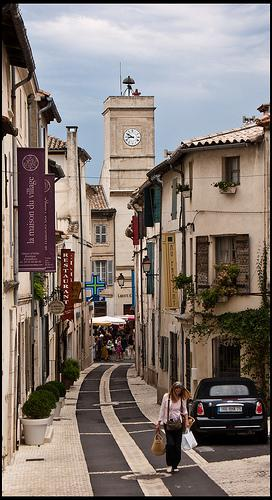State the key elements visible in the picture along with their colors. There is a woman in black pants, a black car, two shopping bags (white and brown), a clock tower, green plants in pots, and hanging banners. Mention the main object of focus in the image and its prominent feature. A woman wearing black pants and carrying white and brown shopping bags is walking on the street. List the items that are being carried or held by someone in the image. tan bag, big white bag, brown shopping bag, white shopping bag Write a sentence describing the most notable action taking place in the image. The woman with long hair, wearing black pants, is walking alone on the street with multiple shopping bags. Explain what the woman in the image might be doing based on her appearance and items she is carrying. The woman seems to be shopping in a foreign city, as she carries multiple shopping bags (white and brown colored) while walking alone on the street. Briefly describe the overall impression the image gives. The image showcases a vibrant street scene in a foreign city with elements like clock tower, store signs, parked cars, and a shopping woman. Describe the atmosphere of the image. The image has a lively atmosphere, capturing a busy street scene with various people and elements such as cars, plants, and store signs. Describe the main characteristics of the street setting in the image. The street is brick-paved with alleyways, buildings lining the side of the road, various store signs hanging outside, and people walking in the background. Provide a brief description of the scene depicted in the image. The image shows a woman walking on a brick-paved street in a foreign city, with various store signs, plants, and parked cars. Mention any element that indicates the location shown in the image. The hanging purple banners with French writing suggest that the scene is in a French-speaking city. 